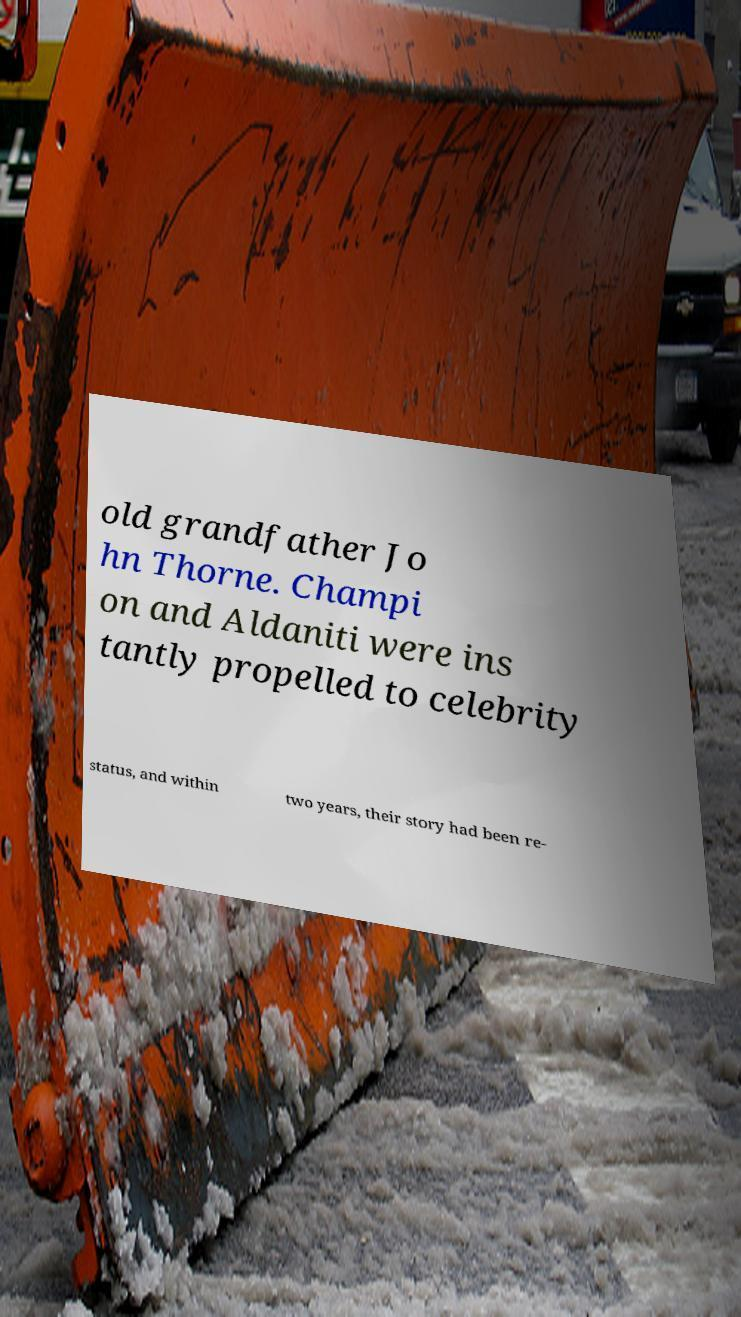Can you read and provide the text displayed in the image?This photo seems to have some interesting text. Can you extract and type it out for me? old grandfather Jo hn Thorne. Champi on and Aldaniti were ins tantly propelled to celebrity status, and within two years, their story had been re- 